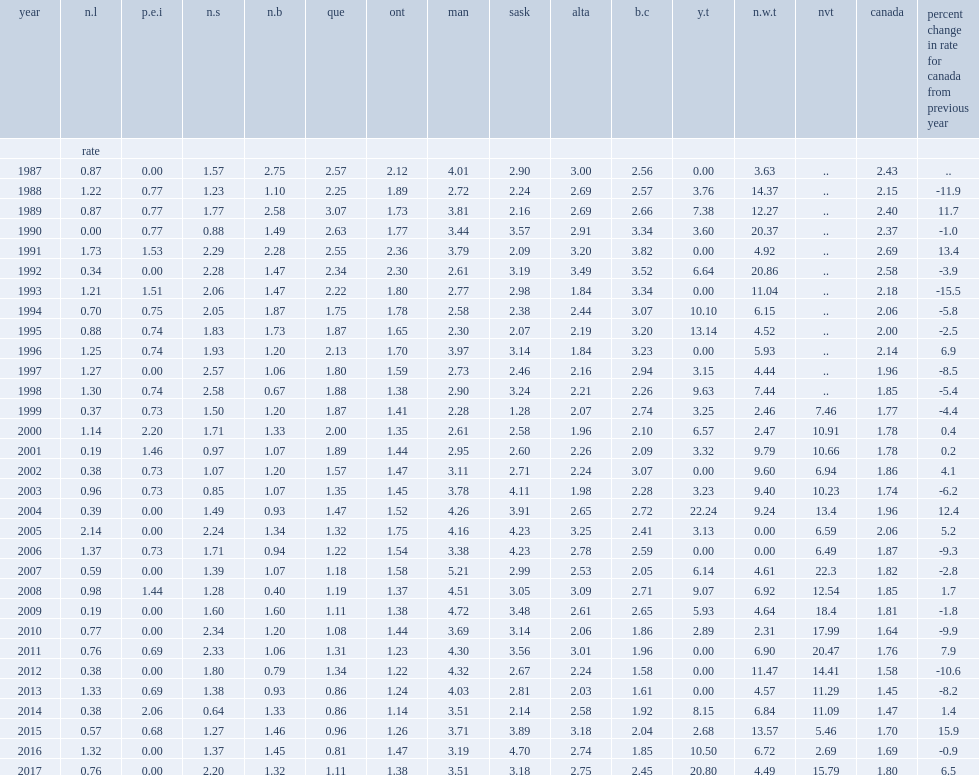How many victims per 100,000 population of canadian people in 2017? 1.8. How many homicides per 100,000 population, british columbia's homicide rate increased by 32%? 2.45. 